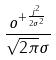<formula> <loc_0><loc_0><loc_500><loc_500>\frac { o ^ { + \frac { j ^ { 2 } } { 2 \sigma ^ { 2 } } } } { \sqrt { 2 \pi } \sigma }</formula> 